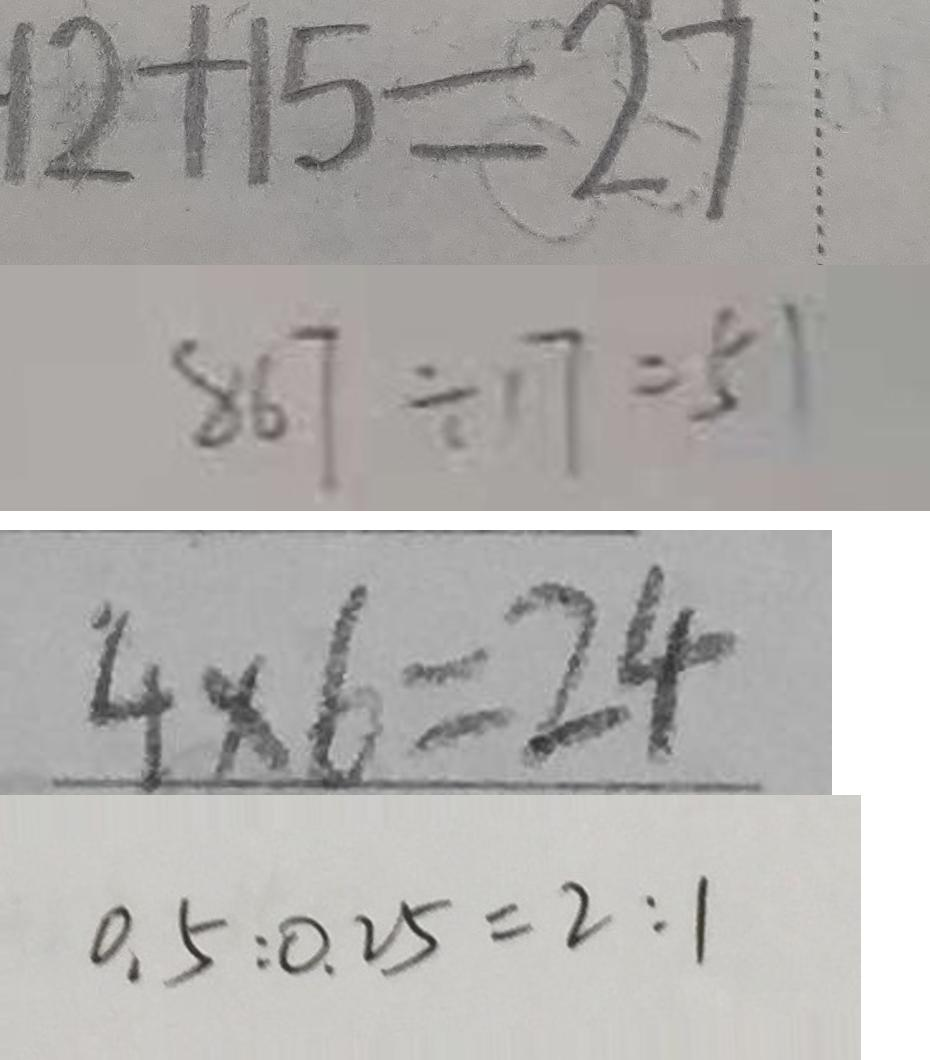<formula> <loc_0><loc_0><loc_500><loc_500>1 2 + 1 5 = 2 7 
 8 6 7 \div 1 7 = 5 1 
 4 \times 6 = 2 4 
 0 . 5 : 0 . 2 5 = 2 : 1</formula> 